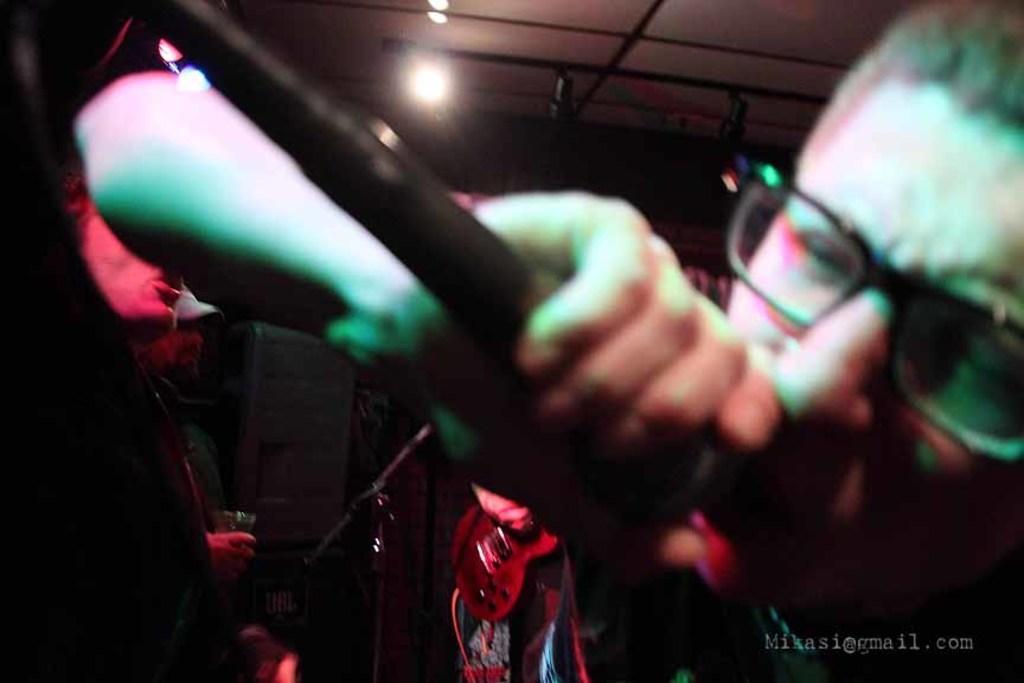Describe this image in one or two sentences. In this image we can see a person wearing spectacles singing a song by using mic. On the backside we can see a person singing, a person holding a glass in his hand and a person holding a guitar. On the backside we can see a roof, lights and a wall. 